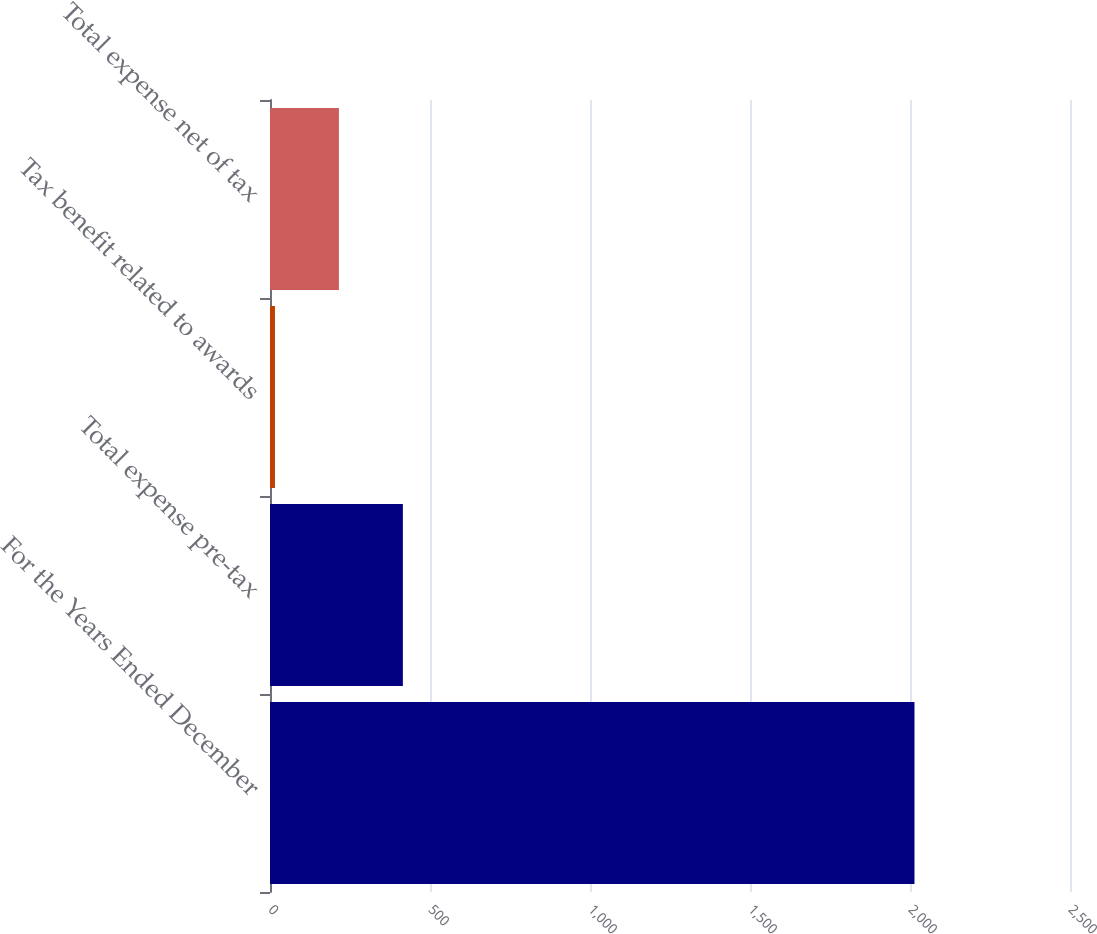Convert chart to OTSL. <chart><loc_0><loc_0><loc_500><loc_500><bar_chart><fcel>For the Years Ended December<fcel>Total expense pre-tax<fcel>Tax benefit related to awards<fcel>Total expense net of tax<nl><fcel>2014<fcel>415.2<fcel>15.5<fcel>215.35<nl></chart> 